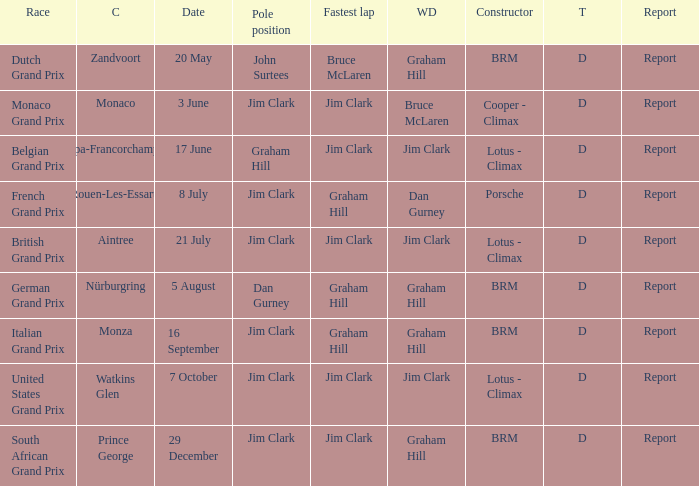What is the tyre on the race where Bruce Mclaren had the fastest lap? D. 